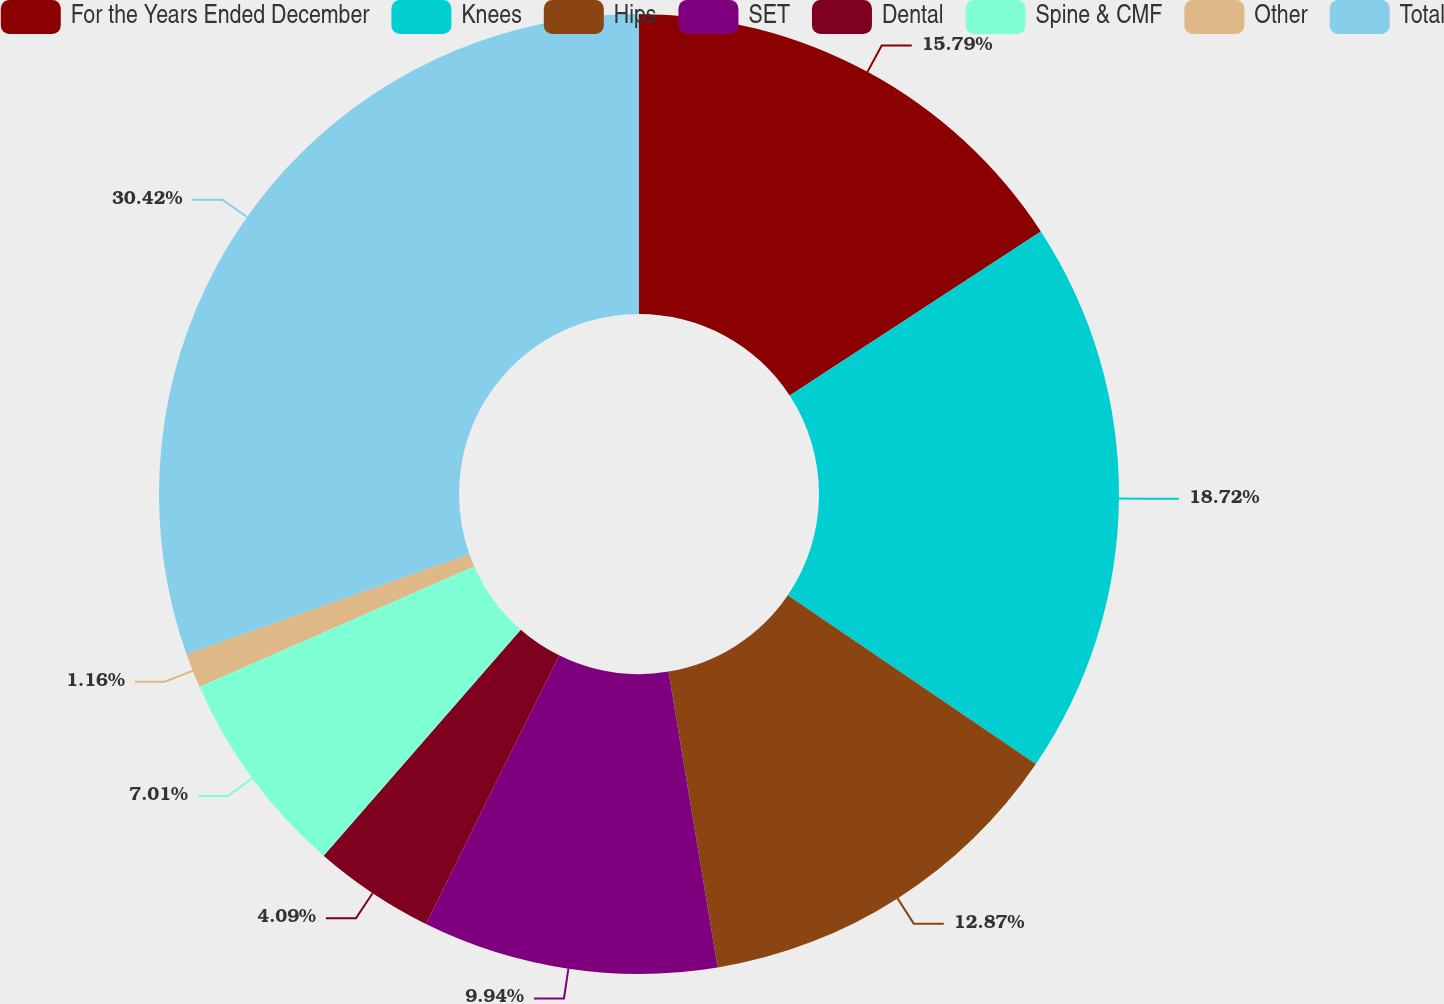<chart> <loc_0><loc_0><loc_500><loc_500><pie_chart><fcel>For the Years Ended December<fcel>Knees<fcel>Hips<fcel>SET<fcel>Dental<fcel>Spine & CMF<fcel>Other<fcel>Total<nl><fcel>15.79%<fcel>18.72%<fcel>12.87%<fcel>9.94%<fcel>4.09%<fcel>7.01%<fcel>1.16%<fcel>30.42%<nl></chart> 